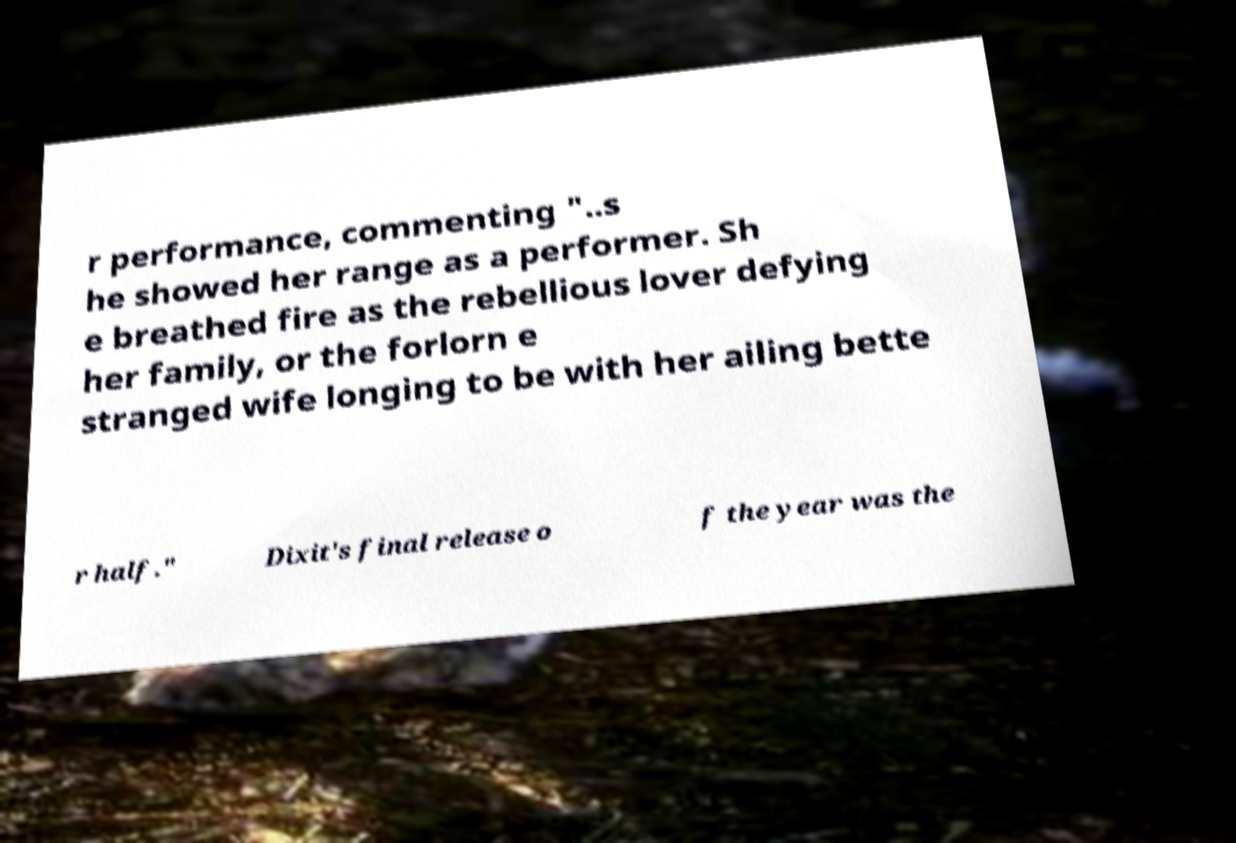Can you accurately transcribe the text from the provided image for me? r performance, commenting "..s he showed her range as a performer. Sh e breathed fire as the rebellious lover defying her family, or the forlorn e stranged wife longing to be with her ailing bette r half." Dixit's final release o f the year was the 